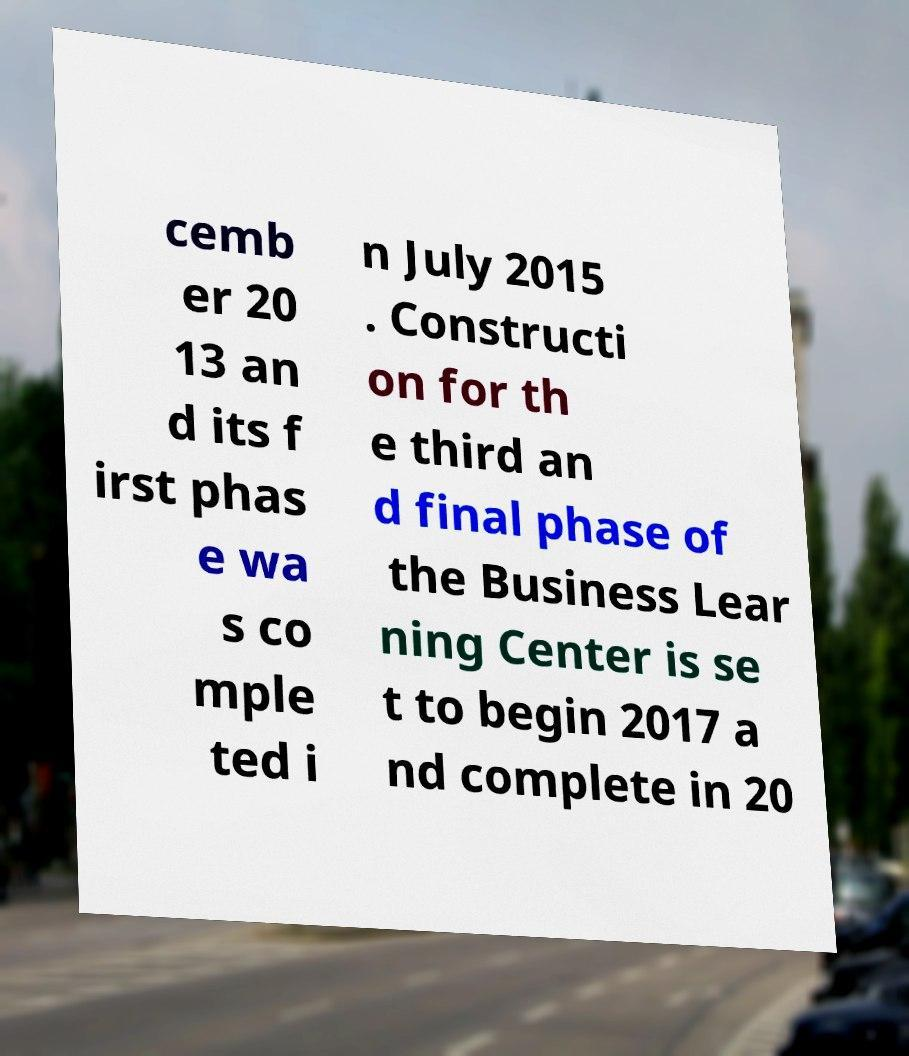Can you read and provide the text displayed in the image?This photo seems to have some interesting text. Can you extract and type it out for me? cemb er 20 13 an d its f irst phas e wa s co mple ted i n July 2015 . Constructi on for th e third an d final phase of the Business Lear ning Center is se t to begin 2017 a nd complete in 20 